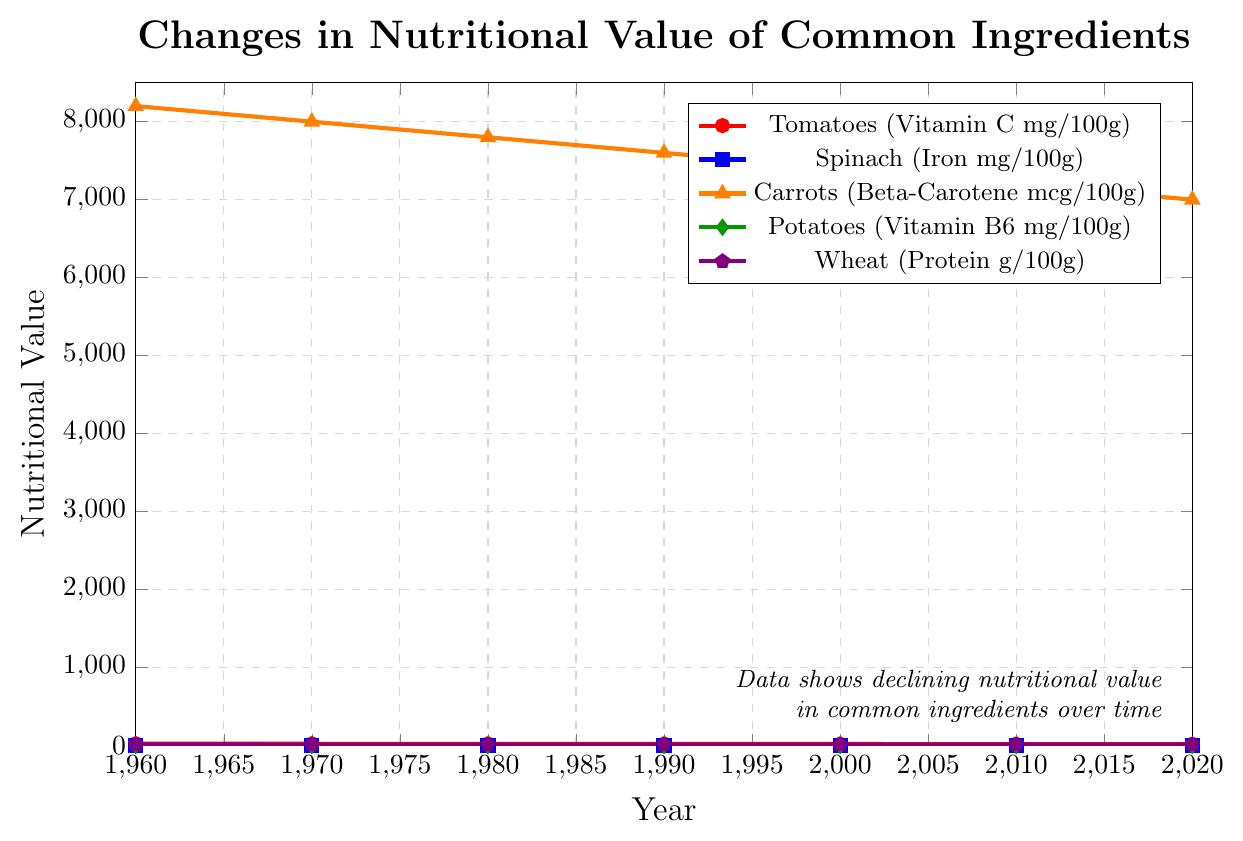Which ingredient experienced the least decline in its nutritional value from 1960 to 2020? Observe the lines in the chart, noting the decline for each ingredient over time. Wheat (Protein g/100g) shows the least decline from 12.5 g/100g to 11.3 g/100g, a difference of 1.2.
Answer: Wheat (Protein) Between which years did carrots experience the largest decrease in Beta-Carotene concentration? Compare the decrease in Beta-Carotene concentration for carrots between each consecutive decade. The largest decrease is between 1960 (8200 mcg/100g) and 1970 (8000 mcg/100g) with a decrease of 200 mcg/100g.
Answer: 1960-1970 What was the average vitamin C content in tomatoes from 1960 to 2020? Calculate the average by summing the vitamin C values for each year (23 + 22 + 21 + 20 + 19 + 18 + 17) = 140 and divide by the number of years (7).
Answer: 20 Which ingredient showed a consistent decrease in nutritional value every decade? Examine the lines and see which one consistently decreases in each period. Every ingredient shown (Tomatoes, Spinach, Carrots, Potatoes, Wheat) exhibits a consistent decrease.
Answer: All How much did the iron content in spinach reduce from 1960 to 2020? Subtract the iron content in spinach in 2020 (2.3 mg/100g) from the value in 1960 (3.5 mg/100g).
Answer: 1.2 Which ingredient had the steepest overall decline in nutritional content? Compare the slope of the lines representing each ingredient over time. Carrots (Beta-Carotene) had the steepest decline from 8200 mcg/100g to 7000 mcg/100g, a difference of 1200.
Answer: Carrots (Beta-Carotene) How did the vitamin B6 content in potatoes change from 1980 to 2000? Subtract the vitamin B6 content in 2000 (0.22 mg/100g) from the content in 1980 (0.26 mg/100g).
Answer: 0.04 In which year was the protein content in wheat closest to 12 g/100g? Identify the protein values across the years and find the one closest to 12 g/100g, which is 1980 (12.1 g/100g).
Answer: 1980 What is the total reduction in vitamin C content in tomatoes from 1960 to 2020? Subtract the vitamin C content in tomatoes in 2020 (17 mg/100g) from the value in 1960 (23 mg/100g).
Answer: 6 Is the nutritional value of Potatoes or Spinach more affected by the agricultural practices, based on the decline from 1960 to 2020? Compare the reduction in values: Potatoes (0.3 mg/100g to 0.18 mg/100g = 0.12) and Spinach (3.5 mg/100g to 2.3 mg/100g = 1.2). Spinach has a larger reduction.
Answer: Spinach 